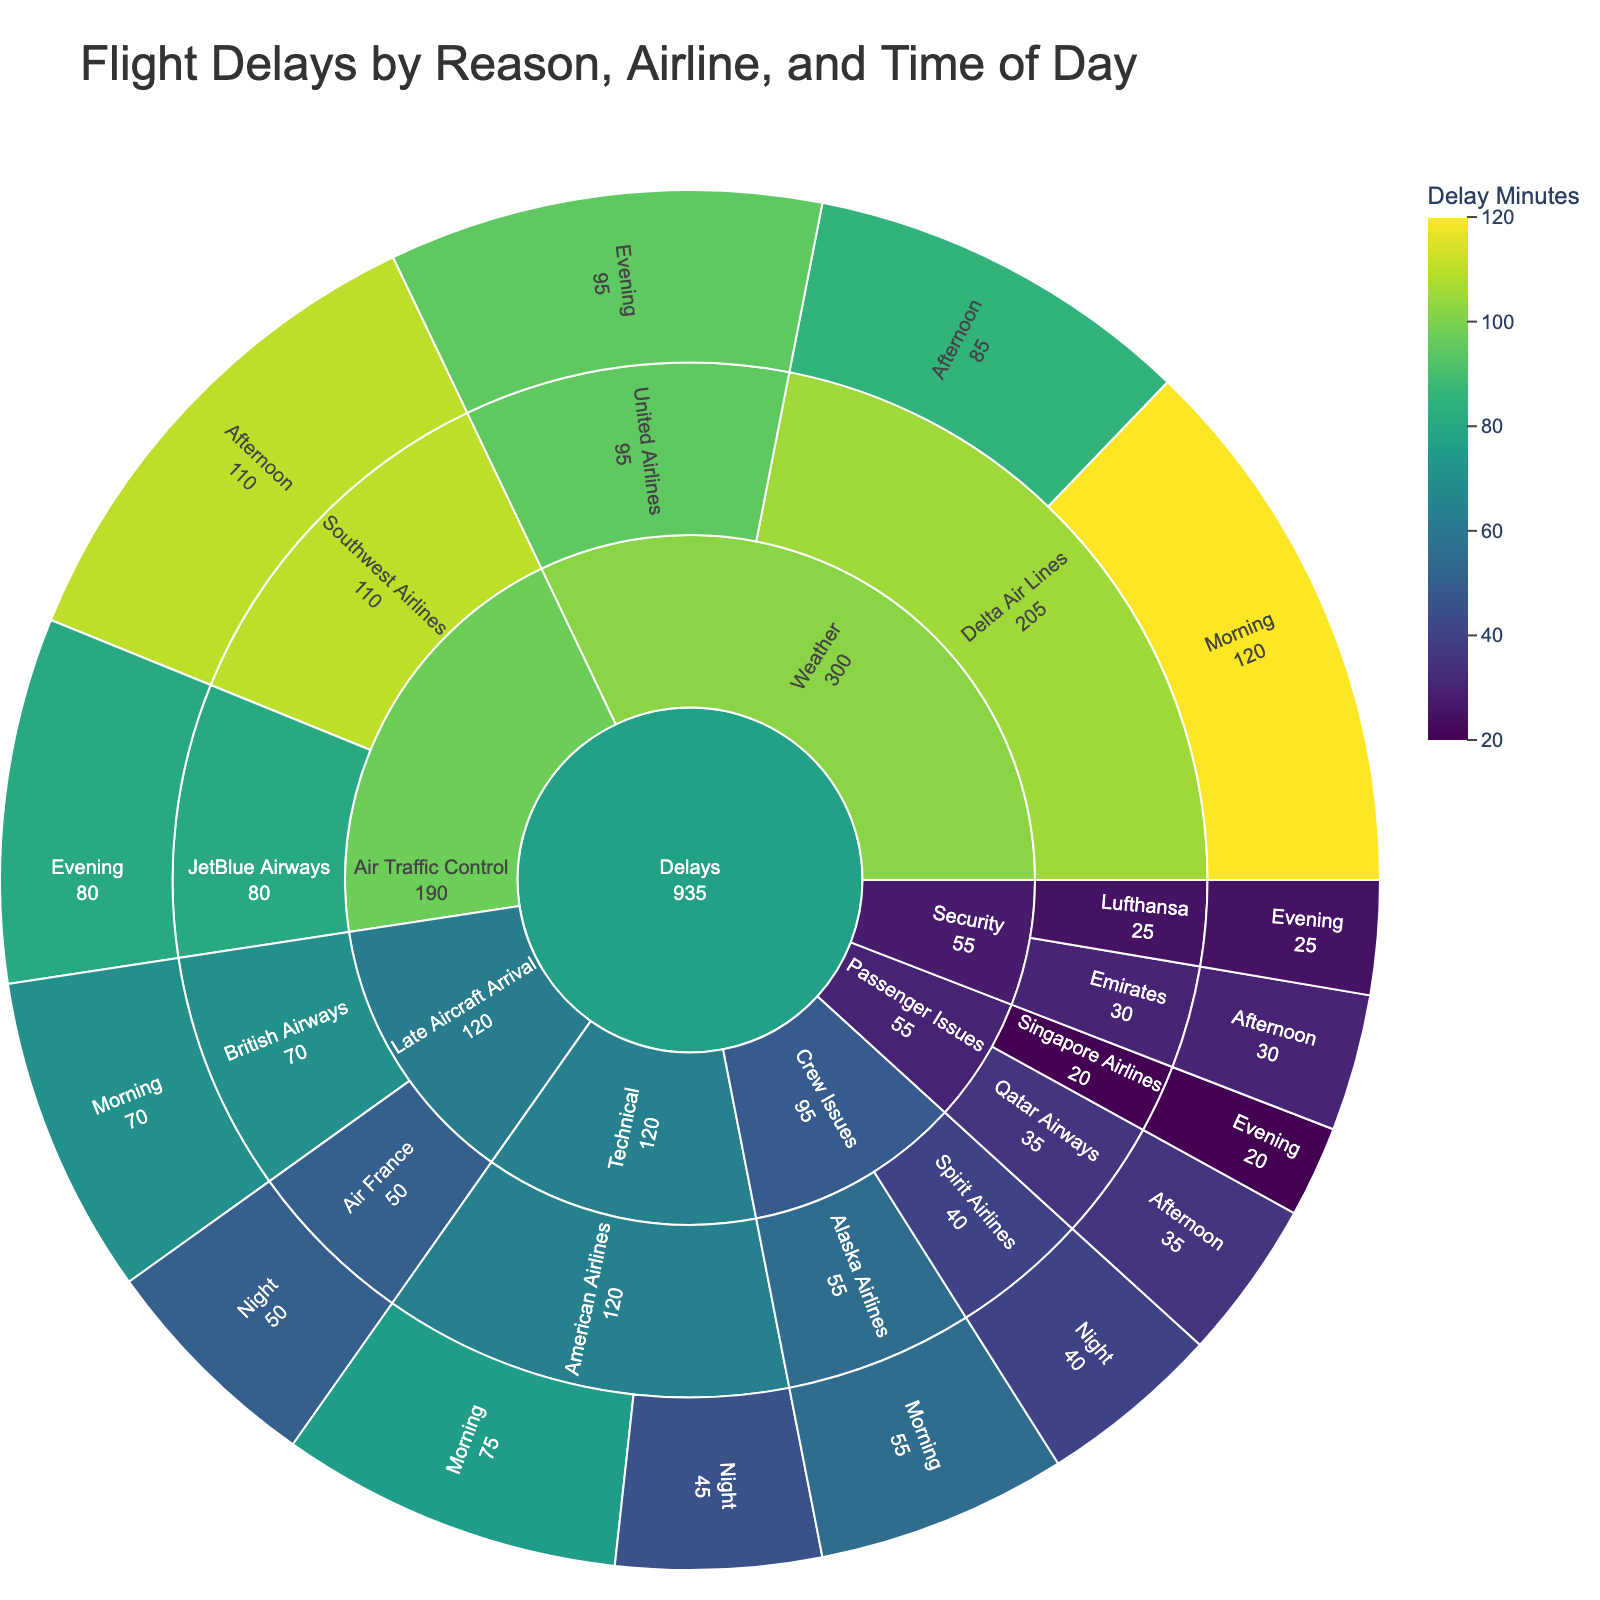What is the total delay in minutes caused by weather for Delta Air Lines? Combine the delays for Delta Air Lines caused by weather in both Morning and Afternoon. The given values are 120 minutes (Morning) and 85 minutes (Afternoon). Therefore, the total delay is 120 + 85 = 205 minutes.
Answer: 205 minutes Which airline experienced the most delays due to technical issues in the morning? Check the airlines listed under the "Technical" category and their corresponding delay values for the morning. American Airlines has a delay of 75 minutes for technical issues in the morning.
Answer: American Airlines Which reason contributed the most to delays in the afternoon? Compare the delay values for different reasons listed in the afternoon. Air Traffic Control delays in the afternoon are 110 minutes, which is the highest among other reasons listed.
Answer: Air Traffic Control What is the combined delay time for crew issues across all airlines? Add up the delay times listed under the "Crew Issues" category. Alaska Airlines (Morning) has 55 minutes and Spirit Airlines (Night) has 40 minutes. The combined total is 55 + 40 = 95 minutes.
Answer: 95 minutes Compare the delay times between technical issues and security issues for all airlines. Which has the higher total delay time? First, sum the delay times for technical and security issues. Technical: American Airlines (Morning: 75, Night: 45) = 75 + 45 = 120 minutes. Security: Emirates (Afternoon: 30), Lufthansa (Evening: 25) = 30 + 25 = 55 minutes. Therefore, technical issues have a higher total delay time.
Answer: Technical issues What is the delay caused by late aircraft arrival in the morning for British Airways? Directly refer to the value listed for British Airways under the "Late Aircraft Arrival" category for the morning. It is 70 minutes.
Answer: 70 minutes Which airline experienced the least delays due to passenger issues? Compare the delay values listed under the "Passenger Issues" category for different airlines. Qatar Airways has 35 minutes delay (Afternoon), and Singapore Airlines has 20 minutes delay (Evening). Singapore Airlines experienced the least delays.
Answer: Singapore Airlines What is the overall median delay value across all reasons and airlines? List out all delay values: 120, 85, 95, 75, 45, 110, 80, 55, 40, 30, 25, 70, 50, 35, 20. Order these values: 20, 25, 30, 35, 40, 45, 50, 55, 70, 75, 80, 85, 95, 110, 120. The median value (middle value) in this ordered list is 55.
Answer: 55 How many airlines had delays due to security issues? Count the number of airlines listed under the "Security" category. There are two airlines: Emirates and Lufthansa.
Answer: Two airlines Which time of day saw the highest delay for any single reason and airline? Scan for the largest individual delay value across all categories. The highest is 120 minutes for Delta Air Lines due to weather in the morning.
Answer: Morning 